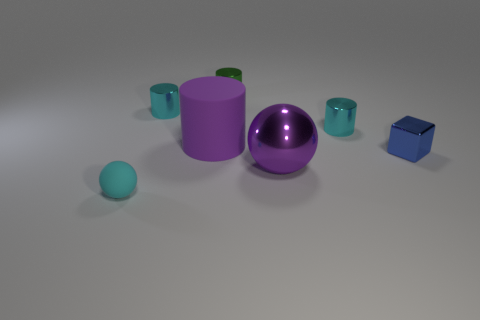What number of objects are big purple objects on the right side of the green thing or cyan rubber balls? In the image, there's one large purple object located on the right side of the green cylinder, and there appears to be one cyan rubber ball as well. So, the total count of these items as per your query is two. 